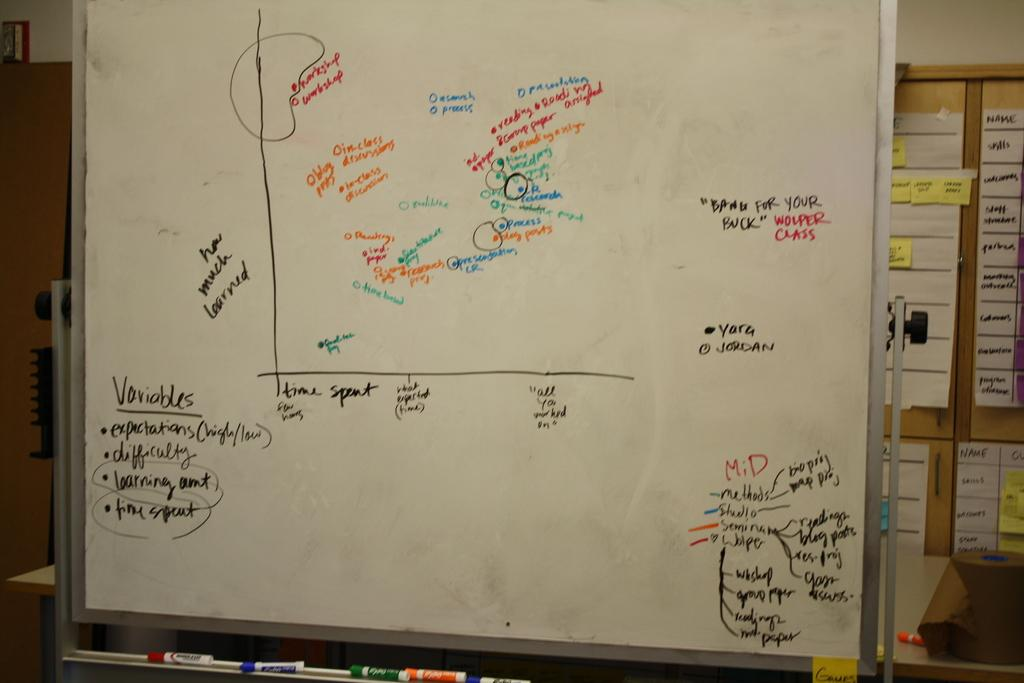<image>
Relay a brief, clear account of the picture shown. A white board with an bar graph and variables wrote on it 